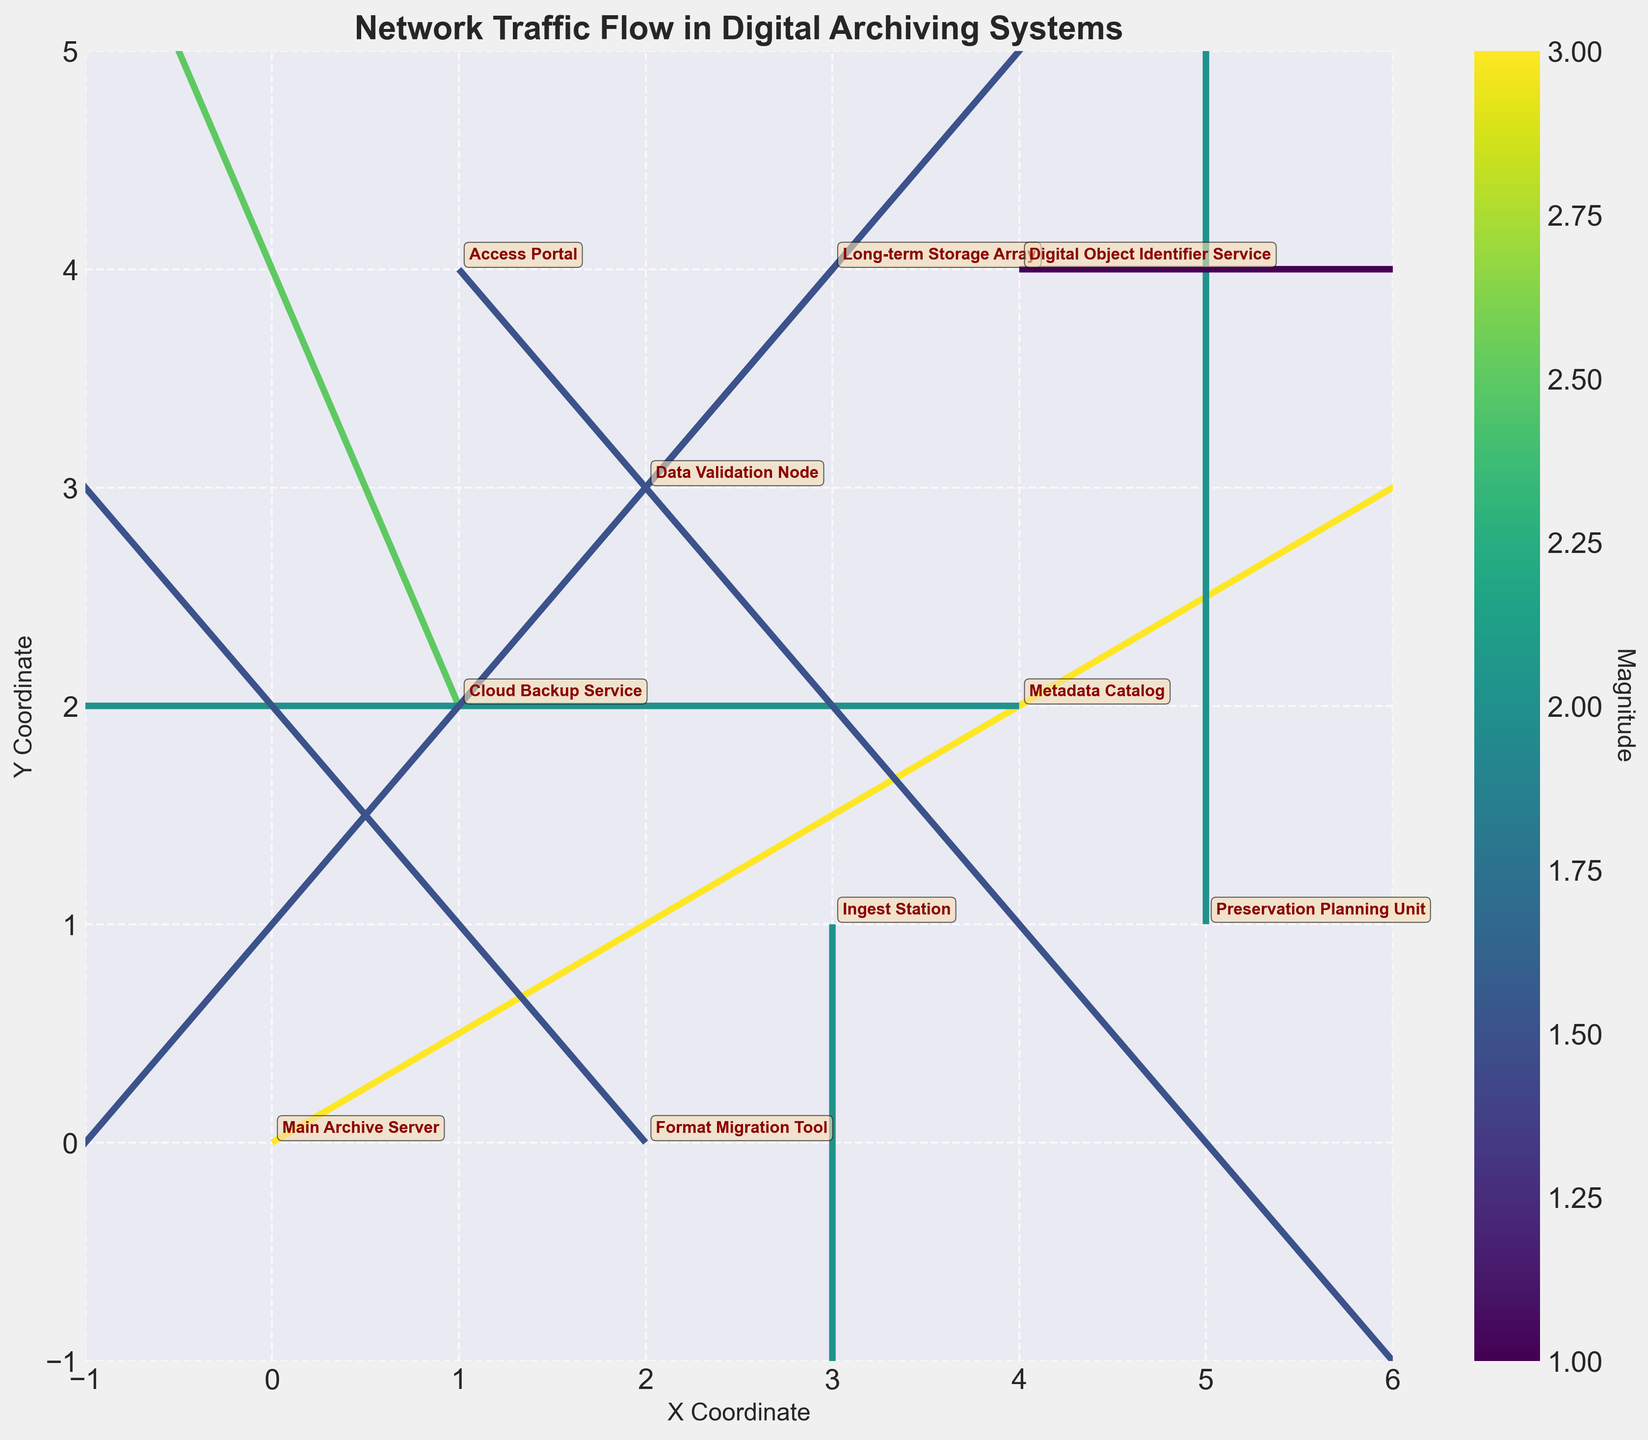What is the title of the plot? The title is displayed prominently at the top of the plot in bold, which reads 'Network Traffic Flow in Digital Archiving Systems'.
Answer: Network Traffic Flow in Digital Archiving Systems How many data points are displayed in the plot? Each quiver arrow represents a data point, there are 10 arrows in the plot, indicating 10 data points.
Answer: 10 Which node has the highest magnitude value in its flow direction? The color bar indicates the magnitude of the flow, and 'Main Archive Server' at (0,0) has the highest magnitude value of 3.
Answer: Main Archive Server What are the coordinates of the 'Metadata Catalog'? The 'Metadata Catalog' coordinates are annotated next to the arrow starting at the respective coordinates. They are at (4, 2).
Answer: (4, 2) What is the direction of the flow from the 'Preservation Planning Unit'? The arrow direction shows the flow, starting at (5,1) and moving vertically upward (U=0, V=2).
Answer: Upward Which node has a negative horizontal flow component? The arrows with negative U values indicate a negative horizontal flow. Both 'Cloud Backup Service' at (1,2) and 'Metadata Catalog' at (4,2) have negative horizontal components.
Answer: Cloud Backup Service, Metadata Catalog What is the average magnitude of all nodes? Sum the magnitudes and divide by the number of nodes: (3 + 2.5 + 2 + 1.5 + 2 + 1.5 + 1.5 + 2 + 1 + 1.5) / 10 = 18.5 / 10 = 1.85.
Answer: 1.85 Which two nodes share the same magnitude but different flow directions? The nodes with the same magnitude can be identified by color intensity and confirmed with their magnitude values. 'Ingest Station' and 'Preservation Planning Unit' both have a magnitude of 2 but different flow directions (downward and upward respectively).
Answer: Ingest Station, Preservation Planning Unit What are the x and y axis labels? The labels are located next to the respective axes. They are 'X Coordinate' for the horizontal axis and 'Y Coordinate' for the vertical axis.
Answer: X Coordinate, Y Coordinate How does the flow direction of 'Access Portal' compare to 'Long-term Storage Array'? By observing the arrows, 'Access Portal' at (1,4) flows downward to the right, while 'Long-term Storage Array' at (3,4) flows downward to the left.
Answer: 'Access Portal' flows downward to the right, 'Long-term Storage Array' flows downward to the left 